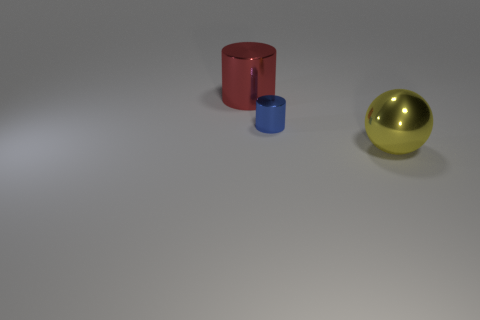Add 3 big blue objects. How many objects exist? 6 Subtract all blue cylinders. How many cylinders are left? 1 Subtract all balls. How many objects are left? 2 Subtract all green spheres. Subtract all red cubes. How many spheres are left? 1 Subtract all gray cubes. How many blue cylinders are left? 1 Subtract all metal spheres. Subtract all big yellow spheres. How many objects are left? 1 Add 2 big shiny balls. How many big shiny balls are left? 3 Add 1 large yellow metallic balls. How many large yellow metallic balls exist? 2 Subtract 0 gray spheres. How many objects are left? 3 Subtract 1 cylinders. How many cylinders are left? 1 